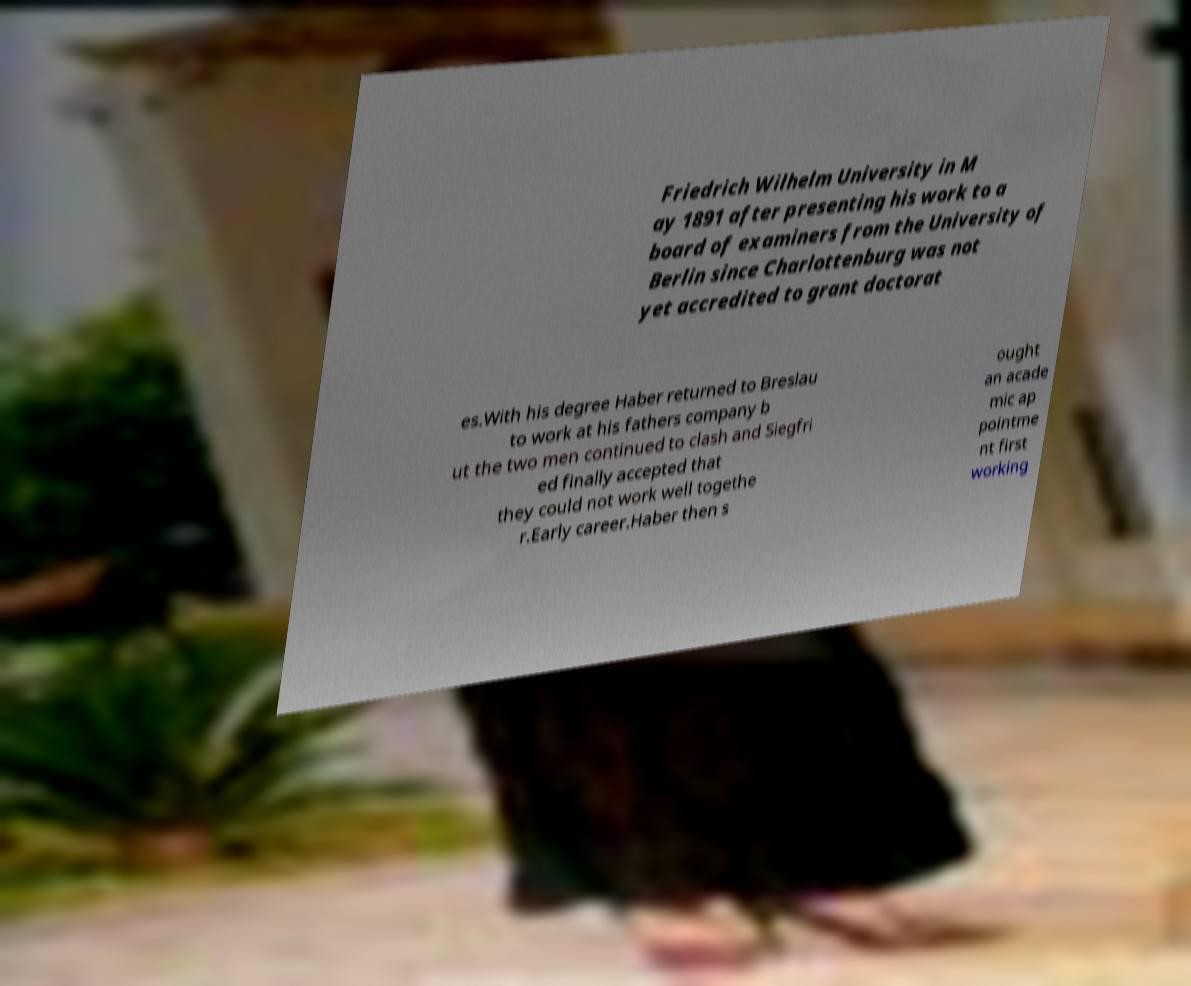Could you extract and type out the text from this image? Friedrich Wilhelm University in M ay 1891 after presenting his work to a board of examiners from the University of Berlin since Charlottenburg was not yet accredited to grant doctorat es.With his degree Haber returned to Breslau to work at his fathers company b ut the two men continued to clash and Siegfri ed finally accepted that they could not work well togethe r.Early career.Haber then s ought an acade mic ap pointme nt first working 